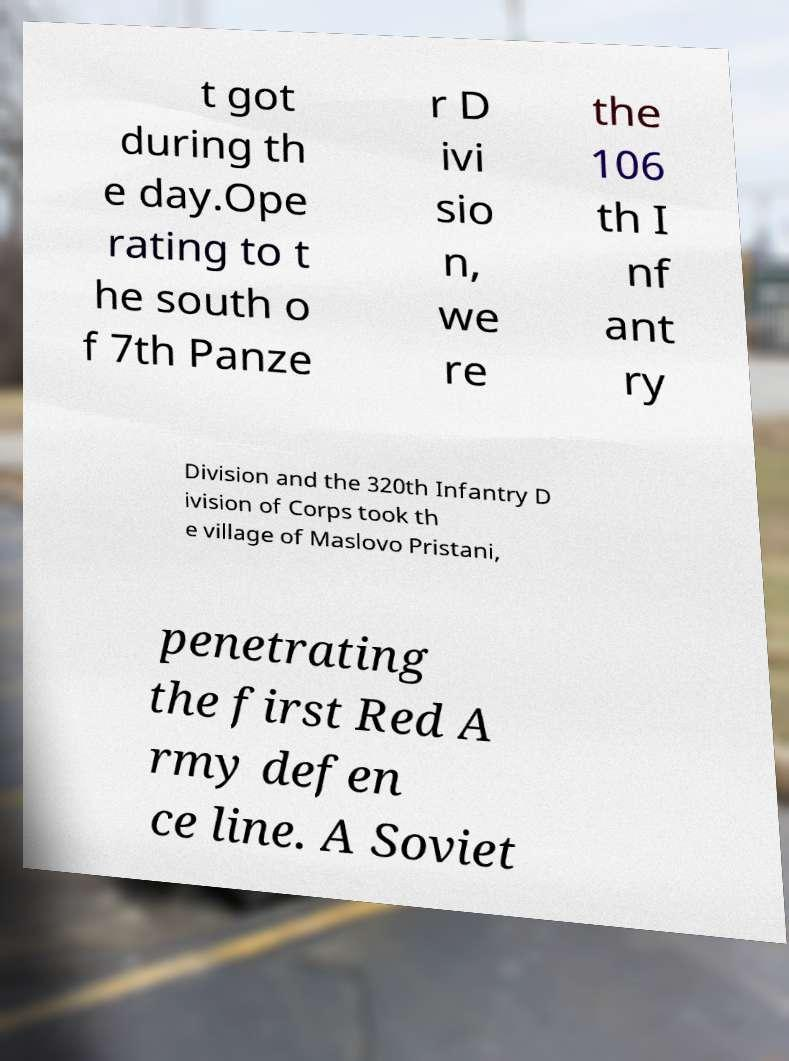Could you assist in decoding the text presented in this image and type it out clearly? t got during th e day.Ope rating to t he south o f 7th Panze r D ivi sio n, we re the 106 th I nf ant ry Division and the 320th Infantry D ivision of Corps took th e village of Maslovo Pristani, penetrating the first Red A rmy defen ce line. A Soviet 